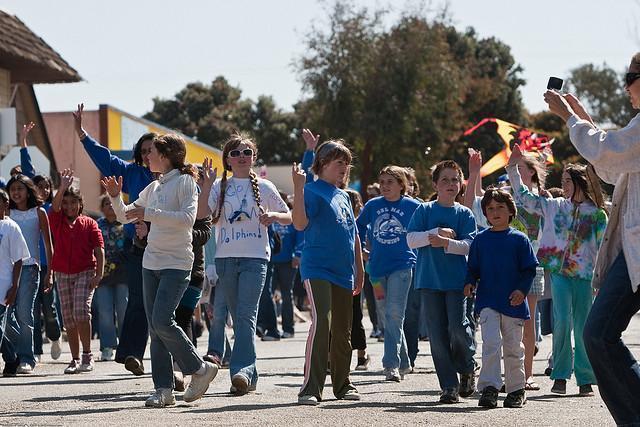Why is the woman on the right holding an object in her hands?
Pick the right solution, then justify: 'Answer: answer
Rationale: rationale.'
Options: Hitting balls, taking photos, exercising, playing games. Answer: taking photos.
Rationale: A woman is holding her phone up, pointed at a crowd of people. 